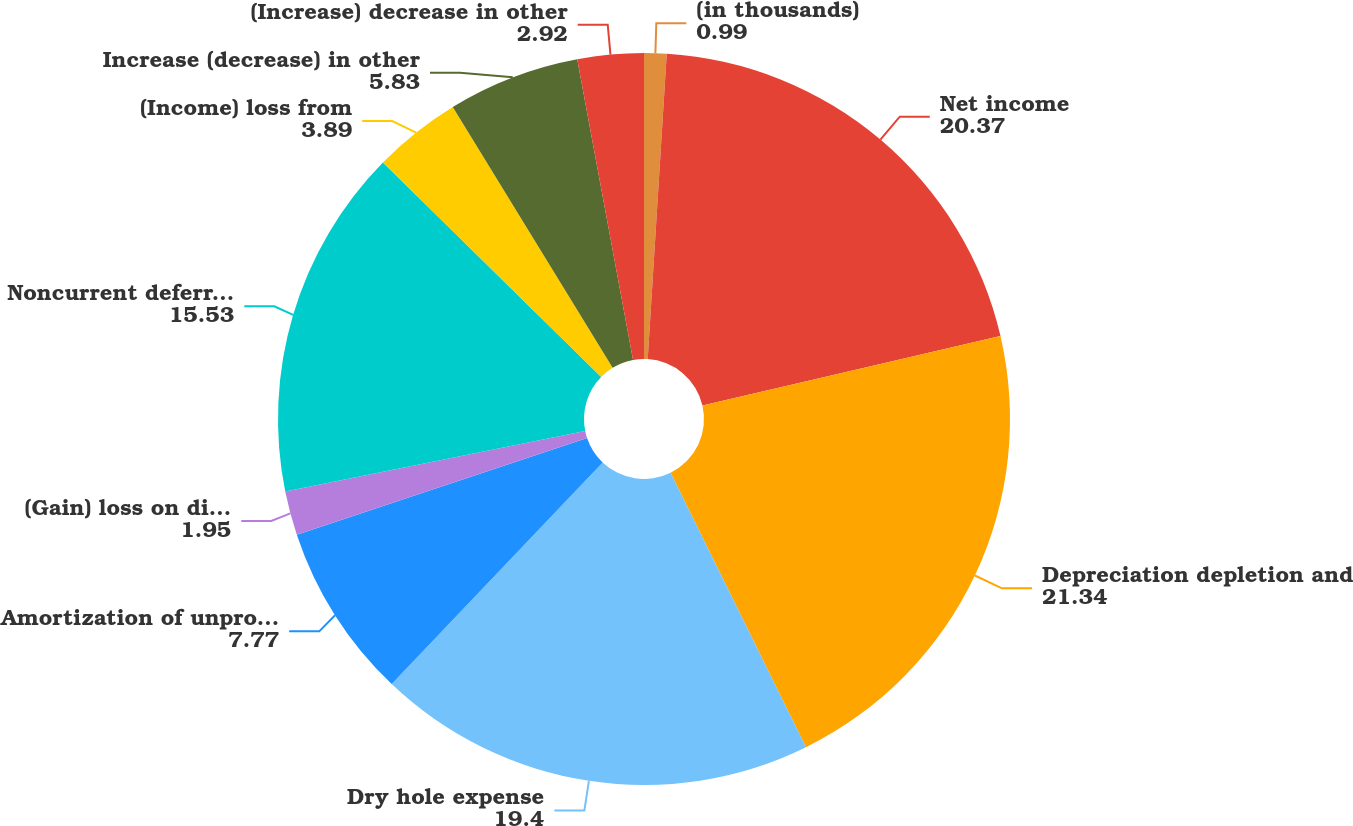Convert chart. <chart><loc_0><loc_0><loc_500><loc_500><pie_chart><fcel>(in thousands)<fcel>Net income<fcel>Depreciation depletion and<fcel>Dry hole expense<fcel>Amortization of unproved<fcel>(Gain) loss on disposal of<fcel>Noncurrent deferred income<fcel>(Income) loss from<fcel>Increase (decrease) in other<fcel>(Increase) decrease in other<nl><fcel>0.99%<fcel>20.37%<fcel>21.34%<fcel>19.4%<fcel>7.77%<fcel>1.95%<fcel>15.53%<fcel>3.89%<fcel>5.83%<fcel>2.92%<nl></chart> 